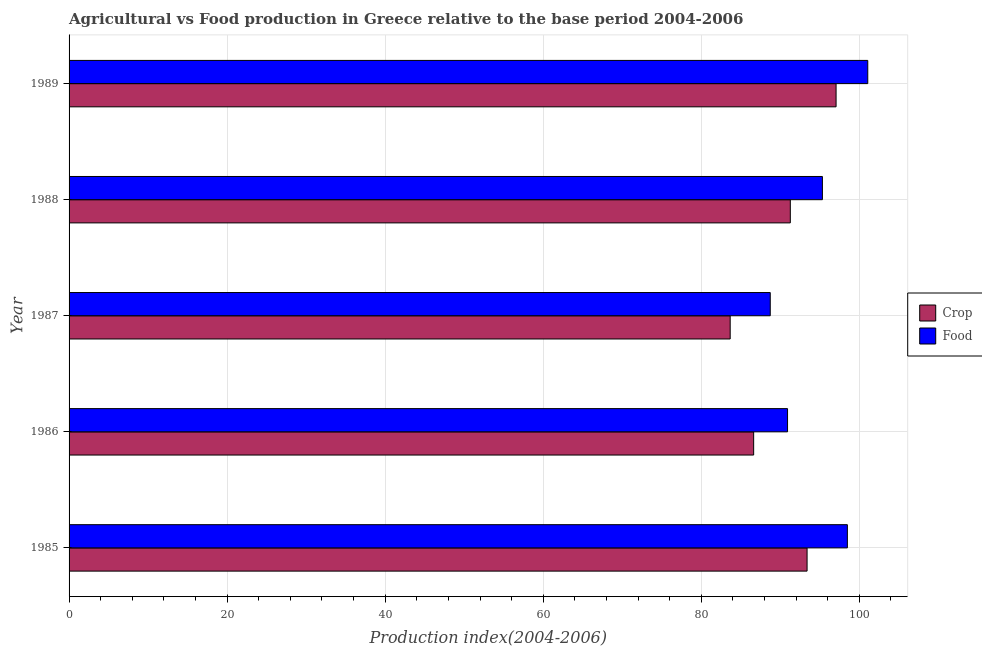How many different coloured bars are there?
Provide a short and direct response. 2. Are the number of bars on each tick of the Y-axis equal?
Provide a succinct answer. Yes. What is the label of the 4th group of bars from the top?
Your response must be concise. 1986. What is the food production index in 1988?
Offer a terse response. 95.33. Across all years, what is the maximum crop production index?
Offer a very short reply. 97.06. Across all years, what is the minimum food production index?
Offer a very short reply. 88.73. What is the total food production index in the graph?
Provide a short and direct response. 474.54. What is the difference between the crop production index in 1985 and that in 1989?
Your answer should be very brief. -3.67. What is the difference between the food production index in 1987 and the crop production index in 1985?
Provide a short and direct response. -4.66. What is the average food production index per year?
Provide a short and direct response. 94.91. In the year 1985, what is the difference between the food production index and crop production index?
Provide a succinct answer. 5.1. In how many years, is the crop production index greater than 4 ?
Your response must be concise. 5. What is the ratio of the food production index in 1986 to that in 1988?
Make the answer very short. 0.95. Is the food production index in 1986 less than that in 1989?
Make the answer very short. Yes. What is the difference between the highest and the second highest food production index?
Ensure brevity in your answer.  2.58. Is the sum of the crop production index in 1986 and 1989 greater than the maximum food production index across all years?
Provide a succinct answer. Yes. What does the 1st bar from the top in 1985 represents?
Keep it short and to the point. Food. What does the 2nd bar from the bottom in 1986 represents?
Offer a very short reply. Food. Are all the bars in the graph horizontal?
Keep it short and to the point. Yes. Are the values on the major ticks of X-axis written in scientific E-notation?
Offer a very short reply. No. Where does the legend appear in the graph?
Make the answer very short. Center right. What is the title of the graph?
Keep it short and to the point. Agricultural vs Food production in Greece relative to the base period 2004-2006. What is the label or title of the X-axis?
Offer a terse response. Production index(2004-2006). What is the label or title of the Y-axis?
Offer a terse response. Year. What is the Production index(2004-2006) in Crop in 1985?
Your answer should be compact. 93.39. What is the Production index(2004-2006) in Food in 1985?
Provide a short and direct response. 98.49. What is the Production index(2004-2006) of Crop in 1986?
Offer a very short reply. 86.63. What is the Production index(2004-2006) in Food in 1986?
Make the answer very short. 90.92. What is the Production index(2004-2006) in Crop in 1987?
Make the answer very short. 83.66. What is the Production index(2004-2006) of Food in 1987?
Keep it short and to the point. 88.73. What is the Production index(2004-2006) in Crop in 1988?
Offer a very short reply. 91.27. What is the Production index(2004-2006) in Food in 1988?
Your response must be concise. 95.33. What is the Production index(2004-2006) in Crop in 1989?
Your response must be concise. 97.06. What is the Production index(2004-2006) in Food in 1989?
Offer a terse response. 101.07. Across all years, what is the maximum Production index(2004-2006) of Crop?
Your response must be concise. 97.06. Across all years, what is the maximum Production index(2004-2006) of Food?
Your answer should be compact. 101.07. Across all years, what is the minimum Production index(2004-2006) of Crop?
Provide a succinct answer. 83.66. Across all years, what is the minimum Production index(2004-2006) in Food?
Make the answer very short. 88.73. What is the total Production index(2004-2006) of Crop in the graph?
Give a very brief answer. 452.01. What is the total Production index(2004-2006) in Food in the graph?
Your answer should be very brief. 474.54. What is the difference between the Production index(2004-2006) in Crop in 1985 and that in 1986?
Provide a succinct answer. 6.76. What is the difference between the Production index(2004-2006) of Food in 1985 and that in 1986?
Your answer should be very brief. 7.57. What is the difference between the Production index(2004-2006) in Crop in 1985 and that in 1987?
Your answer should be very brief. 9.73. What is the difference between the Production index(2004-2006) in Food in 1985 and that in 1987?
Your answer should be very brief. 9.76. What is the difference between the Production index(2004-2006) of Crop in 1985 and that in 1988?
Ensure brevity in your answer.  2.12. What is the difference between the Production index(2004-2006) in Food in 1985 and that in 1988?
Your response must be concise. 3.16. What is the difference between the Production index(2004-2006) in Crop in 1985 and that in 1989?
Your response must be concise. -3.67. What is the difference between the Production index(2004-2006) of Food in 1985 and that in 1989?
Keep it short and to the point. -2.58. What is the difference between the Production index(2004-2006) in Crop in 1986 and that in 1987?
Your response must be concise. 2.97. What is the difference between the Production index(2004-2006) in Food in 1986 and that in 1987?
Offer a very short reply. 2.19. What is the difference between the Production index(2004-2006) of Crop in 1986 and that in 1988?
Your answer should be compact. -4.64. What is the difference between the Production index(2004-2006) of Food in 1986 and that in 1988?
Offer a very short reply. -4.41. What is the difference between the Production index(2004-2006) of Crop in 1986 and that in 1989?
Your answer should be very brief. -10.43. What is the difference between the Production index(2004-2006) in Food in 1986 and that in 1989?
Offer a very short reply. -10.15. What is the difference between the Production index(2004-2006) in Crop in 1987 and that in 1988?
Ensure brevity in your answer.  -7.61. What is the difference between the Production index(2004-2006) in Food in 1987 and that in 1988?
Ensure brevity in your answer.  -6.6. What is the difference between the Production index(2004-2006) in Crop in 1987 and that in 1989?
Ensure brevity in your answer.  -13.4. What is the difference between the Production index(2004-2006) in Food in 1987 and that in 1989?
Keep it short and to the point. -12.34. What is the difference between the Production index(2004-2006) in Crop in 1988 and that in 1989?
Keep it short and to the point. -5.79. What is the difference between the Production index(2004-2006) in Food in 1988 and that in 1989?
Your response must be concise. -5.74. What is the difference between the Production index(2004-2006) in Crop in 1985 and the Production index(2004-2006) in Food in 1986?
Your response must be concise. 2.47. What is the difference between the Production index(2004-2006) of Crop in 1985 and the Production index(2004-2006) of Food in 1987?
Your response must be concise. 4.66. What is the difference between the Production index(2004-2006) of Crop in 1985 and the Production index(2004-2006) of Food in 1988?
Keep it short and to the point. -1.94. What is the difference between the Production index(2004-2006) in Crop in 1985 and the Production index(2004-2006) in Food in 1989?
Your response must be concise. -7.68. What is the difference between the Production index(2004-2006) in Crop in 1986 and the Production index(2004-2006) in Food in 1988?
Your answer should be compact. -8.7. What is the difference between the Production index(2004-2006) in Crop in 1986 and the Production index(2004-2006) in Food in 1989?
Ensure brevity in your answer.  -14.44. What is the difference between the Production index(2004-2006) in Crop in 1987 and the Production index(2004-2006) in Food in 1988?
Keep it short and to the point. -11.67. What is the difference between the Production index(2004-2006) of Crop in 1987 and the Production index(2004-2006) of Food in 1989?
Make the answer very short. -17.41. What is the difference between the Production index(2004-2006) of Crop in 1988 and the Production index(2004-2006) of Food in 1989?
Make the answer very short. -9.8. What is the average Production index(2004-2006) of Crop per year?
Your answer should be compact. 90.4. What is the average Production index(2004-2006) of Food per year?
Make the answer very short. 94.91. In the year 1986, what is the difference between the Production index(2004-2006) in Crop and Production index(2004-2006) in Food?
Keep it short and to the point. -4.29. In the year 1987, what is the difference between the Production index(2004-2006) of Crop and Production index(2004-2006) of Food?
Give a very brief answer. -5.07. In the year 1988, what is the difference between the Production index(2004-2006) of Crop and Production index(2004-2006) of Food?
Your answer should be compact. -4.06. In the year 1989, what is the difference between the Production index(2004-2006) of Crop and Production index(2004-2006) of Food?
Offer a terse response. -4.01. What is the ratio of the Production index(2004-2006) of Crop in 1985 to that in 1986?
Your response must be concise. 1.08. What is the ratio of the Production index(2004-2006) in Crop in 1985 to that in 1987?
Your response must be concise. 1.12. What is the ratio of the Production index(2004-2006) of Food in 1985 to that in 1987?
Provide a succinct answer. 1.11. What is the ratio of the Production index(2004-2006) of Crop in 1985 to that in 1988?
Keep it short and to the point. 1.02. What is the ratio of the Production index(2004-2006) of Food in 1985 to that in 1988?
Keep it short and to the point. 1.03. What is the ratio of the Production index(2004-2006) in Crop in 1985 to that in 1989?
Offer a very short reply. 0.96. What is the ratio of the Production index(2004-2006) of Food in 1985 to that in 1989?
Provide a succinct answer. 0.97. What is the ratio of the Production index(2004-2006) in Crop in 1986 to that in 1987?
Your answer should be very brief. 1.04. What is the ratio of the Production index(2004-2006) in Food in 1986 to that in 1987?
Your answer should be very brief. 1.02. What is the ratio of the Production index(2004-2006) in Crop in 1986 to that in 1988?
Your answer should be compact. 0.95. What is the ratio of the Production index(2004-2006) in Food in 1986 to that in 1988?
Give a very brief answer. 0.95. What is the ratio of the Production index(2004-2006) in Crop in 1986 to that in 1989?
Your response must be concise. 0.89. What is the ratio of the Production index(2004-2006) in Food in 1986 to that in 1989?
Provide a short and direct response. 0.9. What is the ratio of the Production index(2004-2006) of Crop in 1987 to that in 1988?
Your answer should be very brief. 0.92. What is the ratio of the Production index(2004-2006) of Food in 1987 to that in 1988?
Provide a short and direct response. 0.93. What is the ratio of the Production index(2004-2006) in Crop in 1987 to that in 1989?
Your answer should be very brief. 0.86. What is the ratio of the Production index(2004-2006) of Food in 1987 to that in 1989?
Your answer should be very brief. 0.88. What is the ratio of the Production index(2004-2006) of Crop in 1988 to that in 1989?
Offer a terse response. 0.94. What is the ratio of the Production index(2004-2006) of Food in 1988 to that in 1989?
Give a very brief answer. 0.94. What is the difference between the highest and the second highest Production index(2004-2006) in Crop?
Offer a terse response. 3.67. What is the difference between the highest and the second highest Production index(2004-2006) in Food?
Offer a terse response. 2.58. What is the difference between the highest and the lowest Production index(2004-2006) in Food?
Your answer should be very brief. 12.34. 